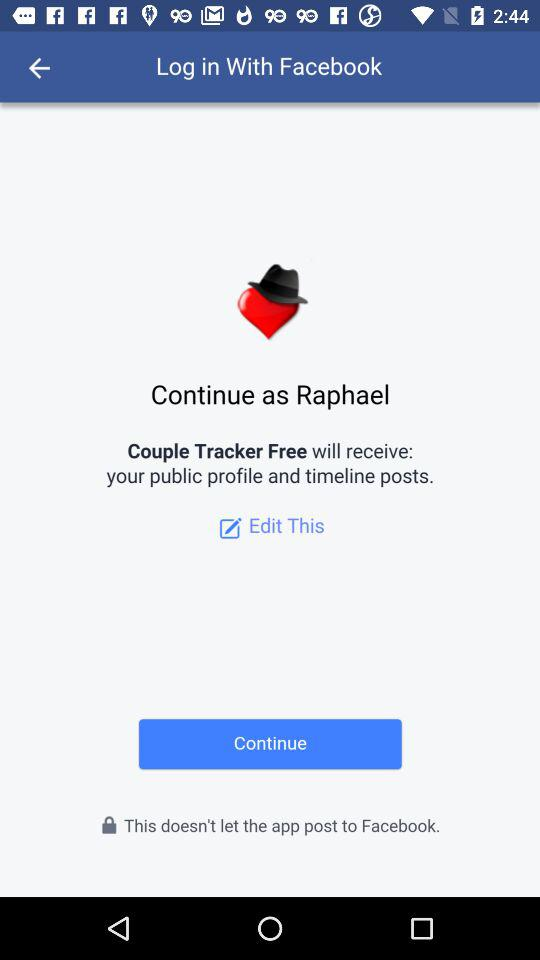What is the user name? The user name is Raphael. 